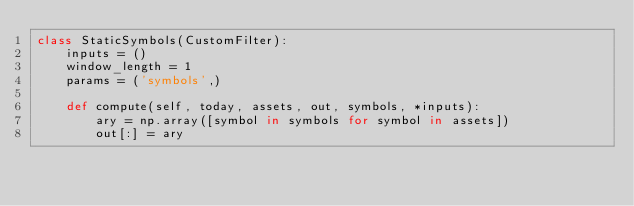Convert code to text. <code><loc_0><loc_0><loc_500><loc_500><_Python_>class StaticSymbols(CustomFilter):
    inputs = ()
    window_length = 1
    params = ('symbols',)

    def compute(self, today, assets, out, symbols, *inputs):
        ary = np.array([symbol in symbols for symbol in assets])
        out[:] = ary
</code> 